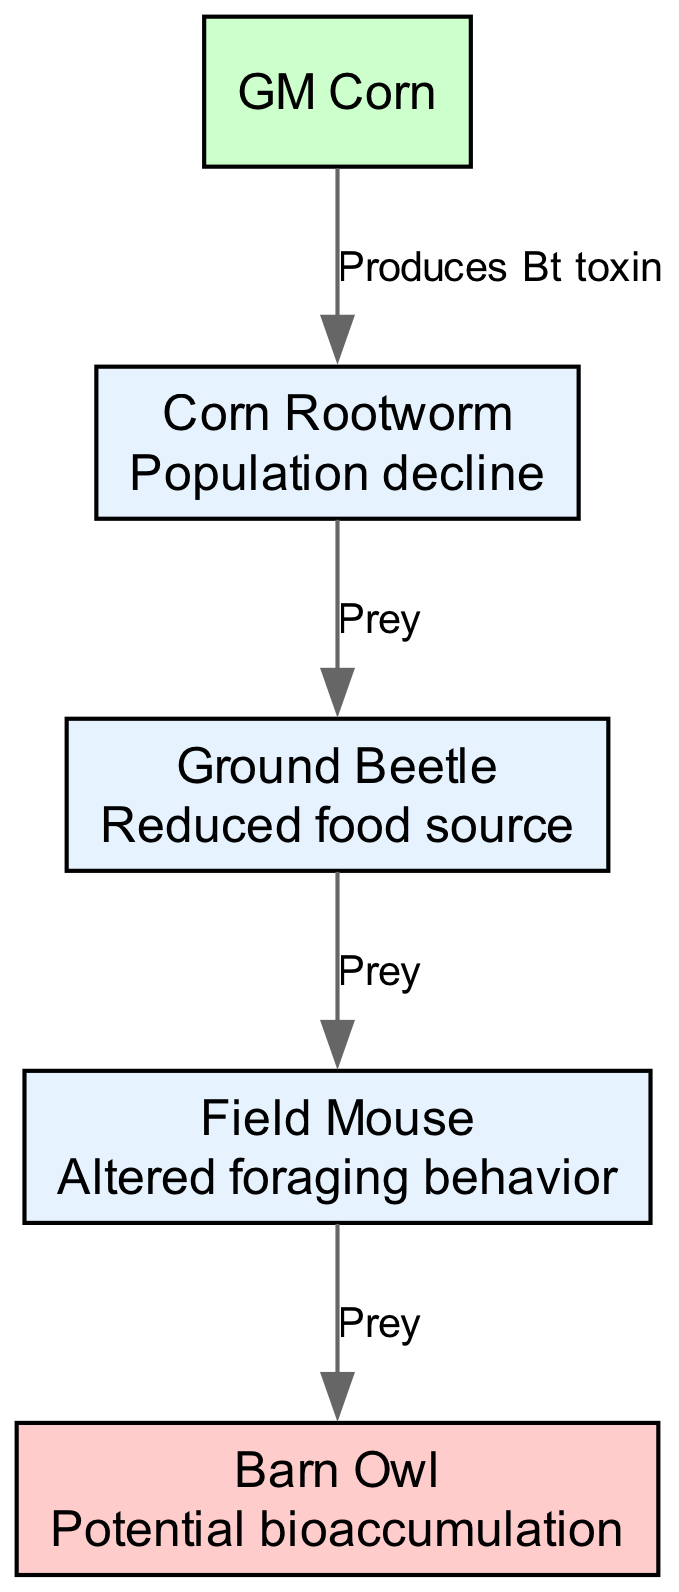What is the starting organism in the food chain? The diagram indicates that GM Corn is the starting organism, as it is the first node in the flow of the food chain.
Answer: GM Corn How many organisms are shown in the diagram? By counting the listed organisms in the data, there are five distinct organisms represented: GM Corn, Corn Rootworm, Ground Beetle, Field Mouse, and Barn Owl.
Answer: 5 What does GM Corn produce that affects Corn Rootworm? The label on the edge from GM Corn to Corn Rootworm specifies that GM Corn "Produces Bt toxin," demonstrating the direct impact on the next organism.
Answer: Bt toxin Which organism is preyed upon by the Ground Beetle? The diagram shows a directed edge from Corn Rootworm to Ground Beetle, indicating that the Ground Beetle preys on Corn Rootworm.
Answer: Corn Rootworm What effect does the introduction of GM Corn have on the Corn Rootworm population? The impact listed for the Corn Rootworm states "Population decline," suggesting that the introduction of GM Corn negatively affects their population.
Answer: Population decline What is the most significant effect observed in the Barn Owl? The information provided indicates that the Barn Owl could experience "Potential bioaccumulation," which suggests a risk associated with its position at the top of the food chain due to accumulation of toxins.
Answer: Potential bioaccumulation How does the introduction of GM Corn affect Field Mouse behavior? The diagram notes that Field Mice experience "Altered foraging behavior," indicating a change in their behavior due to the ecological changes initiated by the introduction of GM Corn.
Answer: Altered foraging behavior What is the relationship type between Ground Beetle and Field Mouse? The diagram shows that the relationship labeled "Prey" exists between Ground Beetle and Field Mouse, meaning the Ground Beetle is a food source for the Field Mouse.
Answer: Prey Which organism is impacted by the effect of "Reduced food source"? According to the effects listed, the Ground Beetle is noted to have "Reduced food source," indicating a drop in its available food due to ecological changes introduced by GM Corn.
Answer: Ground Beetle 